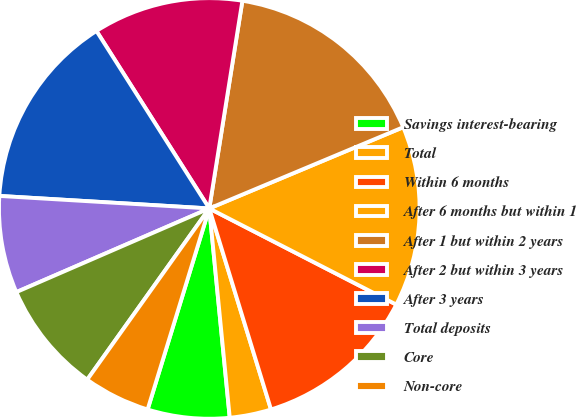Convert chart. <chart><loc_0><loc_0><loc_500><loc_500><pie_chart><fcel>Savings interest-bearing<fcel>Total<fcel>Within 6 months<fcel>After 6 months but within 1<fcel>After 1 but within 2 years<fcel>After 2 but within 3 years<fcel>After 3 years<fcel>Total deposits<fcel>Core<fcel>Non-core<nl><fcel>6.29%<fcel>3.19%<fcel>12.7%<fcel>13.87%<fcel>16.17%<fcel>11.53%<fcel>15.04%<fcel>7.46%<fcel>8.63%<fcel>5.12%<nl></chart> 